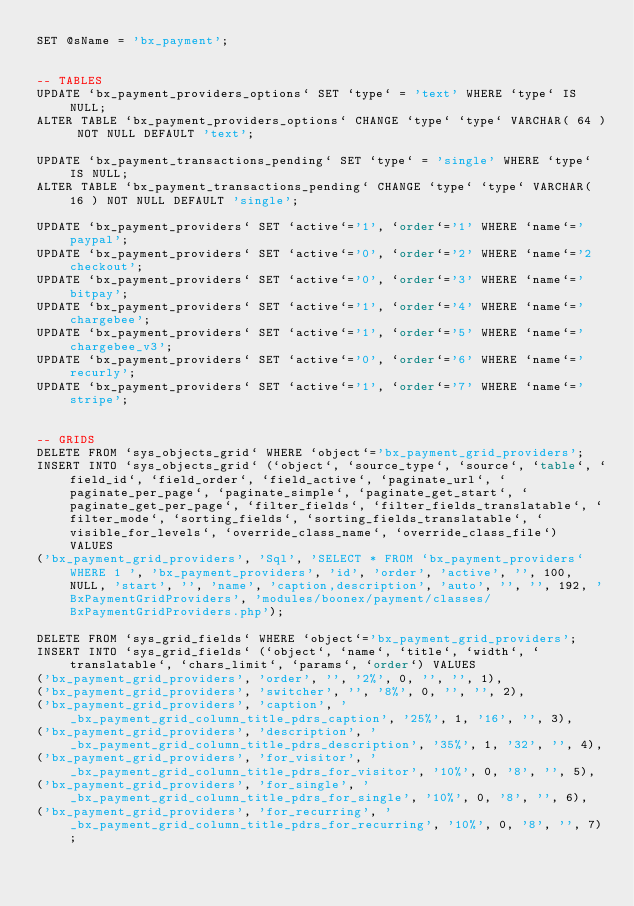Convert code to text. <code><loc_0><loc_0><loc_500><loc_500><_SQL_>SET @sName = 'bx_payment';


-- TABLES
UPDATE `bx_payment_providers_options` SET `type` = 'text' WHERE `type` IS NULL;
ALTER TABLE `bx_payment_providers_options` CHANGE `type` `type` VARCHAR( 64 ) NOT NULL DEFAULT 'text';

UPDATE `bx_payment_transactions_pending` SET `type` = 'single' WHERE `type` IS NULL;
ALTER TABLE `bx_payment_transactions_pending` CHANGE `type` `type` VARCHAR( 16 ) NOT NULL DEFAULT 'single';

UPDATE `bx_payment_providers` SET `active`='1', `order`='1' WHERE `name`='paypal';
UPDATE `bx_payment_providers` SET `active`='0', `order`='2' WHERE `name`='2checkout';
UPDATE `bx_payment_providers` SET `active`='0', `order`='3' WHERE `name`='bitpay';
UPDATE `bx_payment_providers` SET `active`='1', `order`='4' WHERE `name`='chargebee';
UPDATE `bx_payment_providers` SET `active`='1', `order`='5' WHERE `name`='chargebee_v3';
UPDATE `bx_payment_providers` SET `active`='0', `order`='6' WHERE `name`='recurly';
UPDATE `bx_payment_providers` SET `active`='1', `order`='7' WHERE `name`='stripe';


-- GRIDS
DELETE FROM `sys_objects_grid` WHERE `object`='bx_payment_grid_providers';
INSERT INTO `sys_objects_grid` (`object`, `source_type`, `source`, `table`, `field_id`, `field_order`, `field_active`, `paginate_url`, `paginate_per_page`, `paginate_simple`, `paginate_get_start`, `paginate_get_per_page`, `filter_fields`, `filter_fields_translatable`, `filter_mode`, `sorting_fields`, `sorting_fields_translatable`, `visible_for_levels`, `override_class_name`, `override_class_file`) VALUES
('bx_payment_grid_providers', 'Sql', 'SELECT * FROM `bx_payment_providers` WHERE 1 ', 'bx_payment_providers', 'id', 'order', 'active', '', 100, NULL, 'start', '', 'name', 'caption,description', 'auto', '', '', 192, 'BxPaymentGridProviders', 'modules/boonex/payment/classes/BxPaymentGridProviders.php');

DELETE FROM `sys_grid_fields` WHERE `object`='bx_payment_grid_providers';
INSERT INTO `sys_grid_fields` (`object`, `name`, `title`, `width`, `translatable`, `chars_limit`, `params`, `order`) VALUES
('bx_payment_grid_providers', 'order', '', '2%', 0, '', '', 1),
('bx_payment_grid_providers', 'switcher', '', '8%', 0, '', '', 2),
('bx_payment_grid_providers', 'caption', '_bx_payment_grid_column_title_pdrs_caption', '25%', 1, '16', '', 3),
('bx_payment_grid_providers', 'description', '_bx_payment_grid_column_title_pdrs_description', '35%', 1, '32', '', 4),
('bx_payment_grid_providers', 'for_visitor', '_bx_payment_grid_column_title_pdrs_for_visitor', '10%', 0, '8', '', 5),
('bx_payment_grid_providers', 'for_single', '_bx_payment_grid_column_title_pdrs_for_single', '10%', 0, '8', '', 6),
('bx_payment_grid_providers', 'for_recurring', '_bx_payment_grid_column_title_pdrs_for_recurring', '10%', 0, '8', '', 7);
</code> 